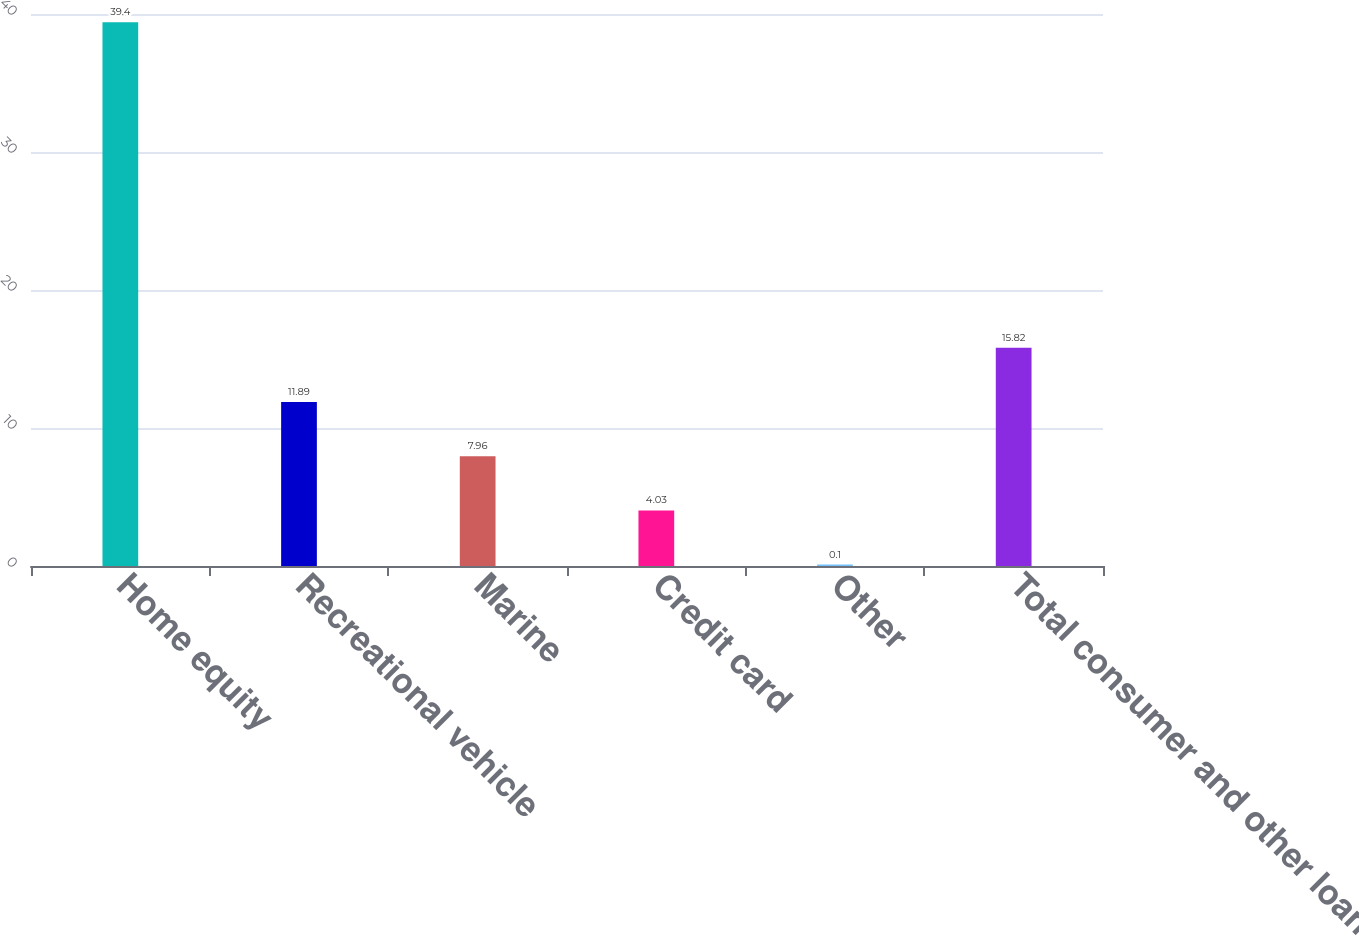Convert chart to OTSL. <chart><loc_0><loc_0><loc_500><loc_500><bar_chart><fcel>Home equity<fcel>Recreational vehicle<fcel>Marine<fcel>Credit card<fcel>Other<fcel>Total consumer and other loans<nl><fcel>39.4<fcel>11.89<fcel>7.96<fcel>4.03<fcel>0.1<fcel>15.82<nl></chart> 